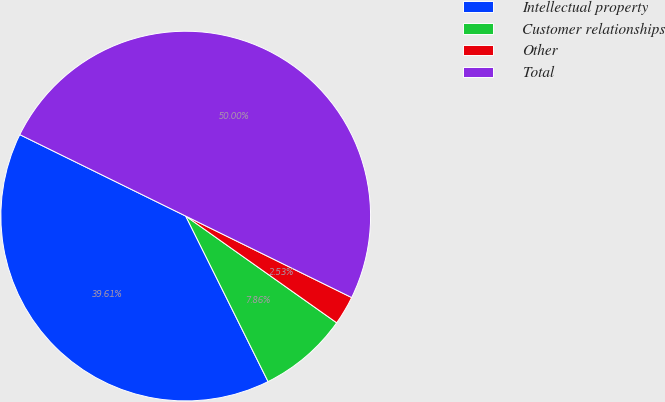<chart> <loc_0><loc_0><loc_500><loc_500><pie_chart><fcel>Intellectual property<fcel>Customer relationships<fcel>Other<fcel>Total<nl><fcel>39.61%<fcel>7.86%<fcel>2.53%<fcel>50.0%<nl></chart> 